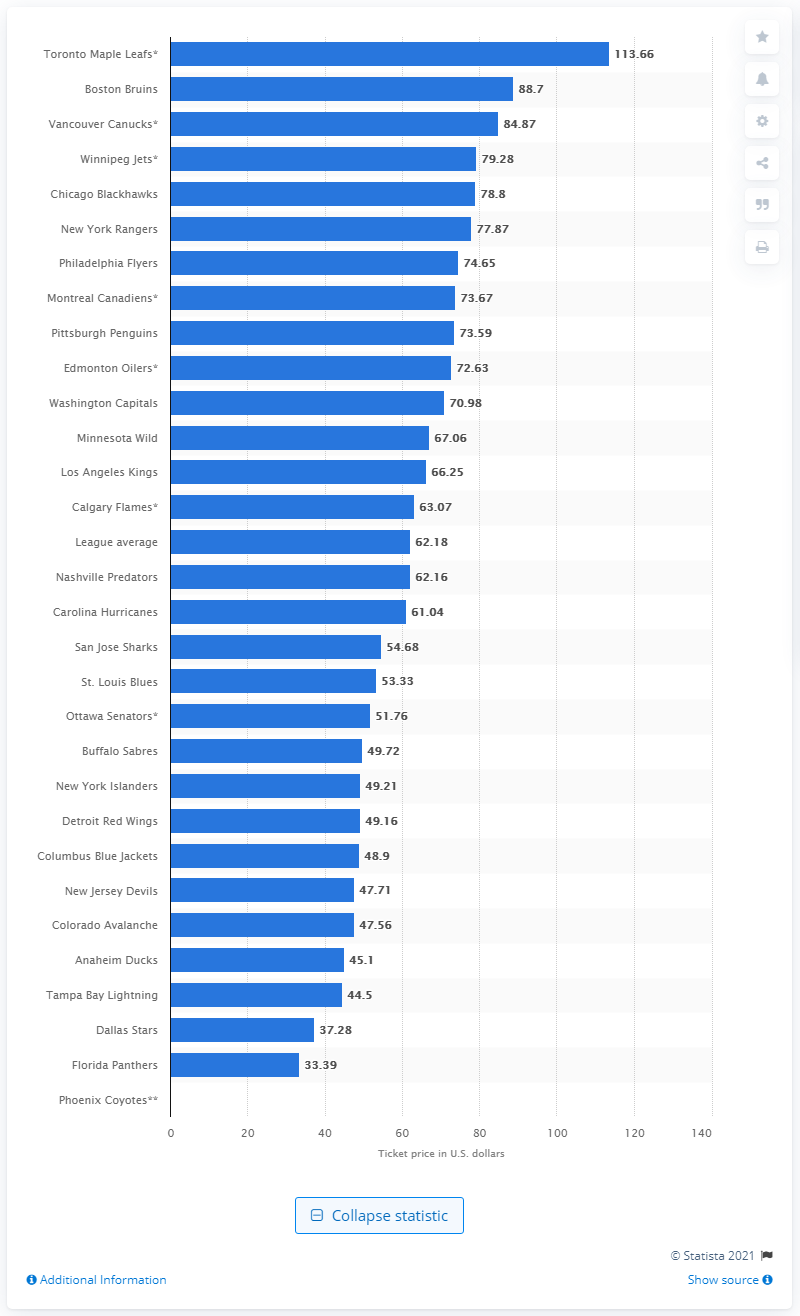Outline some significant characteristics in this image. According to the given data, the average ticket price for a Nashville Predators game was $62.16. 